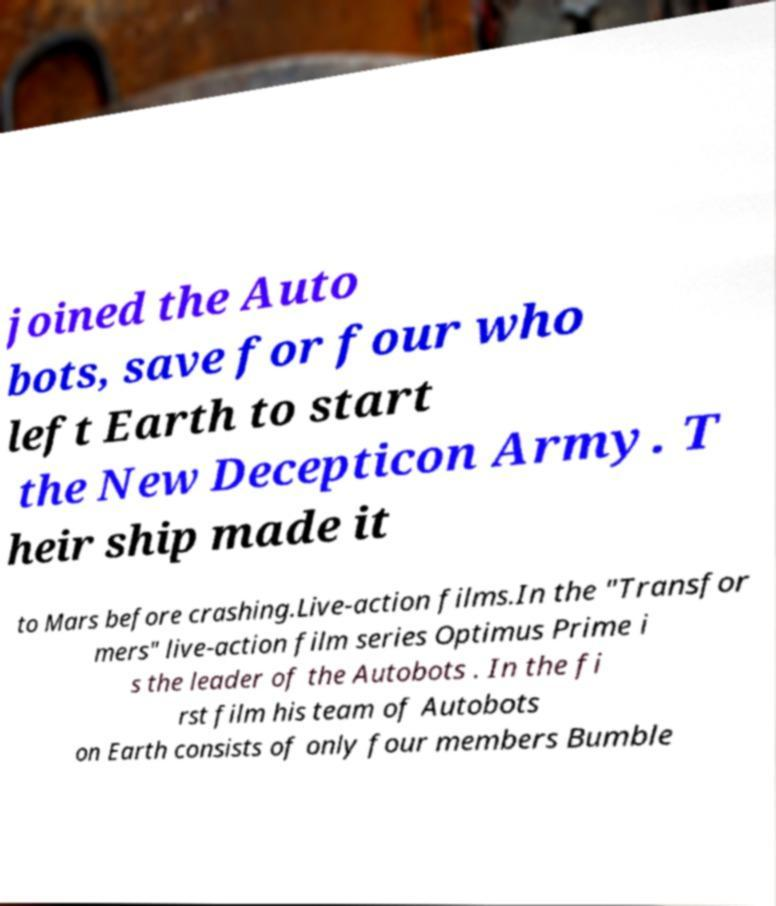Can you read and provide the text displayed in the image?This photo seems to have some interesting text. Can you extract and type it out for me? joined the Auto bots, save for four who left Earth to start the New Decepticon Army. T heir ship made it to Mars before crashing.Live-action films.In the "Transfor mers" live-action film series Optimus Prime i s the leader of the Autobots . In the fi rst film his team of Autobots on Earth consists of only four members Bumble 